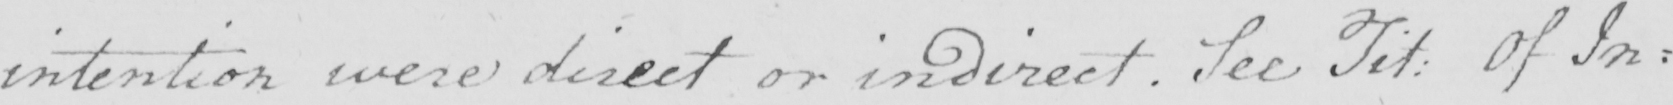What is written in this line of handwriting? intention were direct or indirect . See Tit :  Of In= 